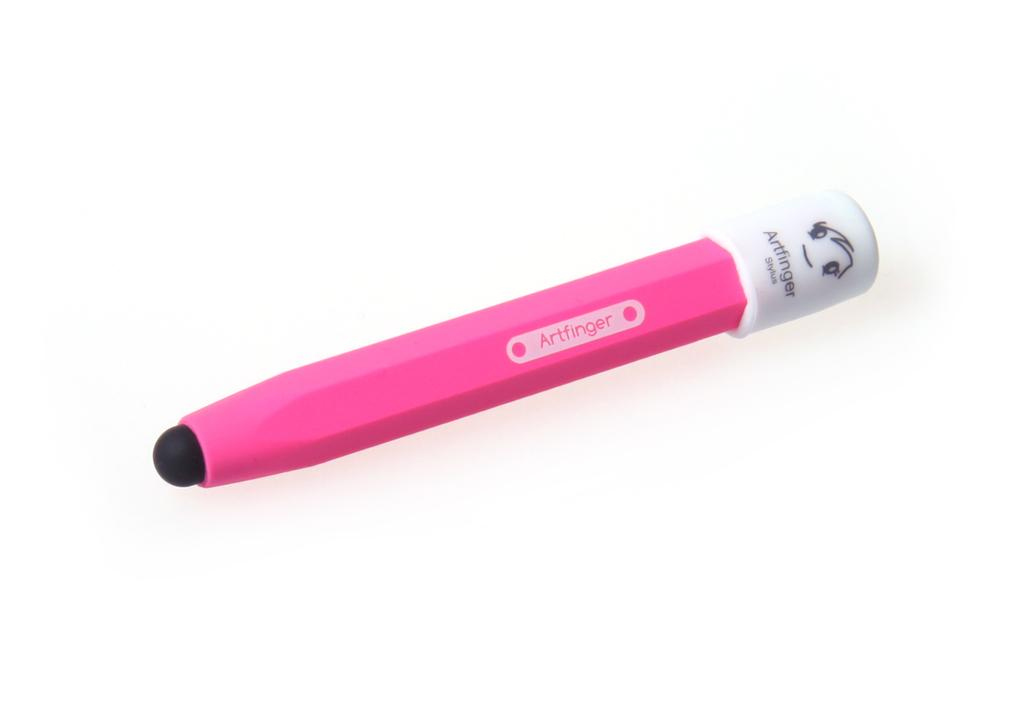What color is the pencil in the image? The pencil in the image is pink. What is written on the pencil? The pencil has "art finger" written on it. What is the background color in the image? The background in the image is white. How many pairs of shoes are visible in the image? There are no shoes visible in the image; it only features a pink pencil with "art finger" written on it against a white background. 